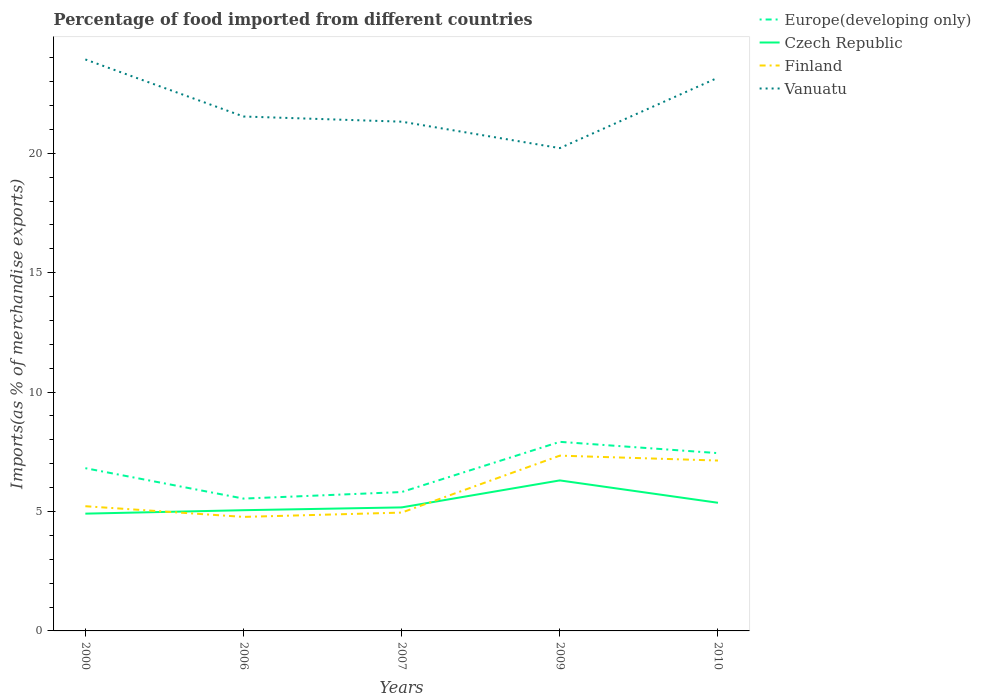How many different coloured lines are there?
Offer a very short reply. 4. Is the number of lines equal to the number of legend labels?
Your response must be concise. Yes. Across all years, what is the maximum percentage of imports to different countries in Europe(developing only)?
Your answer should be compact. 5.54. In which year was the percentage of imports to different countries in Europe(developing only) maximum?
Ensure brevity in your answer.  2006. What is the total percentage of imports to different countries in Finland in the graph?
Offer a terse response. -2.18. What is the difference between the highest and the second highest percentage of imports to different countries in Vanuatu?
Ensure brevity in your answer.  3.71. Is the percentage of imports to different countries in Vanuatu strictly greater than the percentage of imports to different countries in Europe(developing only) over the years?
Your response must be concise. No. How many years are there in the graph?
Keep it short and to the point. 5. Does the graph contain any zero values?
Your answer should be very brief. No. How are the legend labels stacked?
Give a very brief answer. Vertical. What is the title of the graph?
Your answer should be very brief. Percentage of food imported from different countries. Does "Isle of Man" appear as one of the legend labels in the graph?
Make the answer very short. No. What is the label or title of the X-axis?
Your answer should be compact. Years. What is the label or title of the Y-axis?
Make the answer very short. Imports(as % of merchandise exports). What is the Imports(as % of merchandise exports) of Europe(developing only) in 2000?
Make the answer very short. 6.81. What is the Imports(as % of merchandise exports) of Czech Republic in 2000?
Make the answer very short. 4.91. What is the Imports(as % of merchandise exports) in Finland in 2000?
Provide a short and direct response. 5.22. What is the Imports(as % of merchandise exports) in Vanuatu in 2000?
Your answer should be very brief. 23.93. What is the Imports(as % of merchandise exports) in Europe(developing only) in 2006?
Make the answer very short. 5.54. What is the Imports(as % of merchandise exports) in Czech Republic in 2006?
Your answer should be very brief. 5.05. What is the Imports(as % of merchandise exports) in Finland in 2006?
Your response must be concise. 4.77. What is the Imports(as % of merchandise exports) of Vanuatu in 2006?
Your answer should be very brief. 21.54. What is the Imports(as % of merchandise exports) in Europe(developing only) in 2007?
Provide a short and direct response. 5.82. What is the Imports(as % of merchandise exports) of Czech Republic in 2007?
Keep it short and to the point. 5.17. What is the Imports(as % of merchandise exports) in Finland in 2007?
Give a very brief answer. 4.96. What is the Imports(as % of merchandise exports) in Vanuatu in 2007?
Provide a succinct answer. 21.32. What is the Imports(as % of merchandise exports) of Europe(developing only) in 2009?
Provide a succinct answer. 7.92. What is the Imports(as % of merchandise exports) in Czech Republic in 2009?
Keep it short and to the point. 6.3. What is the Imports(as % of merchandise exports) of Finland in 2009?
Your answer should be compact. 7.34. What is the Imports(as % of merchandise exports) of Vanuatu in 2009?
Provide a succinct answer. 20.22. What is the Imports(as % of merchandise exports) of Europe(developing only) in 2010?
Provide a short and direct response. 7.45. What is the Imports(as % of merchandise exports) of Czech Republic in 2010?
Your answer should be compact. 5.37. What is the Imports(as % of merchandise exports) of Finland in 2010?
Your answer should be compact. 7.13. What is the Imports(as % of merchandise exports) in Vanuatu in 2010?
Ensure brevity in your answer.  23.17. Across all years, what is the maximum Imports(as % of merchandise exports) in Europe(developing only)?
Your answer should be very brief. 7.92. Across all years, what is the maximum Imports(as % of merchandise exports) of Czech Republic?
Your response must be concise. 6.3. Across all years, what is the maximum Imports(as % of merchandise exports) of Finland?
Make the answer very short. 7.34. Across all years, what is the maximum Imports(as % of merchandise exports) in Vanuatu?
Offer a very short reply. 23.93. Across all years, what is the minimum Imports(as % of merchandise exports) in Europe(developing only)?
Ensure brevity in your answer.  5.54. Across all years, what is the minimum Imports(as % of merchandise exports) in Czech Republic?
Your response must be concise. 4.91. Across all years, what is the minimum Imports(as % of merchandise exports) of Finland?
Keep it short and to the point. 4.77. Across all years, what is the minimum Imports(as % of merchandise exports) in Vanuatu?
Your response must be concise. 20.22. What is the total Imports(as % of merchandise exports) of Europe(developing only) in the graph?
Offer a terse response. 33.53. What is the total Imports(as % of merchandise exports) in Czech Republic in the graph?
Give a very brief answer. 26.81. What is the total Imports(as % of merchandise exports) of Finland in the graph?
Offer a very short reply. 29.43. What is the total Imports(as % of merchandise exports) in Vanuatu in the graph?
Give a very brief answer. 110.18. What is the difference between the Imports(as % of merchandise exports) in Europe(developing only) in 2000 and that in 2006?
Make the answer very short. 1.27. What is the difference between the Imports(as % of merchandise exports) of Czech Republic in 2000 and that in 2006?
Offer a terse response. -0.14. What is the difference between the Imports(as % of merchandise exports) in Finland in 2000 and that in 2006?
Provide a succinct answer. 0.45. What is the difference between the Imports(as % of merchandise exports) of Vanuatu in 2000 and that in 2006?
Provide a succinct answer. 2.39. What is the difference between the Imports(as % of merchandise exports) in Czech Republic in 2000 and that in 2007?
Ensure brevity in your answer.  -0.26. What is the difference between the Imports(as % of merchandise exports) of Finland in 2000 and that in 2007?
Your answer should be very brief. 0.27. What is the difference between the Imports(as % of merchandise exports) in Vanuatu in 2000 and that in 2007?
Offer a terse response. 2.61. What is the difference between the Imports(as % of merchandise exports) of Europe(developing only) in 2000 and that in 2009?
Keep it short and to the point. -1.1. What is the difference between the Imports(as % of merchandise exports) in Czech Republic in 2000 and that in 2009?
Offer a terse response. -1.39. What is the difference between the Imports(as % of merchandise exports) in Finland in 2000 and that in 2009?
Offer a terse response. -2.12. What is the difference between the Imports(as % of merchandise exports) of Vanuatu in 2000 and that in 2009?
Make the answer very short. 3.71. What is the difference between the Imports(as % of merchandise exports) of Europe(developing only) in 2000 and that in 2010?
Offer a terse response. -0.63. What is the difference between the Imports(as % of merchandise exports) in Czech Republic in 2000 and that in 2010?
Provide a short and direct response. -0.46. What is the difference between the Imports(as % of merchandise exports) of Finland in 2000 and that in 2010?
Your answer should be compact. -1.91. What is the difference between the Imports(as % of merchandise exports) of Vanuatu in 2000 and that in 2010?
Offer a terse response. 0.76. What is the difference between the Imports(as % of merchandise exports) in Europe(developing only) in 2006 and that in 2007?
Your response must be concise. -0.27. What is the difference between the Imports(as % of merchandise exports) in Czech Republic in 2006 and that in 2007?
Your answer should be compact. -0.12. What is the difference between the Imports(as % of merchandise exports) of Finland in 2006 and that in 2007?
Provide a short and direct response. -0.18. What is the difference between the Imports(as % of merchandise exports) of Vanuatu in 2006 and that in 2007?
Offer a very short reply. 0.22. What is the difference between the Imports(as % of merchandise exports) of Europe(developing only) in 2006 and that in 2009?
Provide a succinct answer. -2.38. What is the difference between the Imports(as % of merchandise exports) of Czech Republic in 2006 and that in 2009?
Your response must be concise. -1.25. What is the difference between the Imports(as % of merchandise exports) in Finland in 2006 and that in 2009?
Offer a terse response. -2.57. What is the difference between the Imports(as % of merchandise exports) of Vanuatu in 2006 and that in 2009?
Offer a terse response. 1.32. What is the difference between the Imports(as % of merchandise exports) of Europe(developing only) in 2006 and that in 2010?
Your response must be concise. -1.9. What is the difference between the Imports(as % of merchandise exports) in Czech Republic in 2006 and that in 2010?
Offer a very short reply. -0.31. What is the difference between the Imports(as % of merchandise exports) in Finland in 2006 and that in 2010?
Your answer should be compact. -2.36. What is the difference between the Imports(as % of merchandise exports) in Vanuatu in 2006 and that in 2010?
Provide a succinct answer. -1.63. What is the difference between the Imports(as % of merchandise exports) in Europe(developing only) in 2007 and that in 2009?
Give a very brief answer. -2.1. What is the difference between the Imports(as % of merchandise exports) in Czech Republic in 2007 and that in 2009?
Provide a short and direct response. -1.13. What is the difference between the Imports(as % of merchandise exports) of Finland in 2007 and that in 2009?
Your answer should be very brief. -2.38. What is the difference between the Imports(as % of merchandise exports) in Vanuatu in 2007 and that in 2009?
Your response must be concise. 1.11. What is the difference between the Imports(as % of merchandise exports) in Europe(developing only) in 2007 and that in 2010?
Your answer should be compact. -1.63. What is the difference between the Imports(as % of merchandise exports) of Czech Republic in 2007 and that in 2010?
Offer a very short reply. -0.19. What is the difference between the Imports(as % of merchandise exports) of Finland in 2007 and that in 2010?
Ensure brevity in your answer.  -2.18. What is the difference between the Imports(as % of merchandise exports) of Vanuatu in 2007 and that in 2010?
Keep it short and to the point. -1.84. What is the difference between the Imports(as % of merchandise exports) of Europe(developing only) in 2009 and that in 2010?
Offer a terse response. 0.47. What is the difference between the Imports(as % of merchandise exports) of Czech Republic in 2009 and that in 2010?
Provide a succinct answer. 0.94. What is the difference between the Imports(as % of merchandise exports) in Finland in 2009 and that in 2010?
Ensure brevity in your answer.  0.21. What is the difference between the Imports(as % of merchandise exports) in Vanuatu in 2009 and that in 2010?
Provide a short and direct response. -2.95. What is the difference between the Imports(as % of merchandise exports) of Europe(developing only) in 2000 and the Imports(as % of merchandise exports) of Czech Republic in 2006?
Ensure brevity in your answer.  1.76. What is the difference between the Imports(as % of merchandise exports) in Europe(developing only) in 2000 and the Imports(as % of merchandise exports) in Finland in 2006?
Your answer should be very brief. 2.04. What is the difference between the Imports(as % of merchandise exports) of Europe(developing only) in 2000 and the Imports(as % of merchandise exports) of Vanuatu in 2006?
Ensure brevity in your answer.  -14.73. What is the difference between the Imports(as % of merchandise exports) in Czech Republic in 2000 and the Imports(as % of merchandise exports) in Finland in 2006?
Ensure brevity in your answer.  0.14. What is the difference between the Imports(as % of merchandise exports) in Czech Republic in 2000 and the Imports(as % of merchandise exports) in Vanuatu in 2006?
Keep it short and to the point. -16.63. What is the difference between the Imports(as % of merchandise exports) in Finland in 2000 and the Imports(as % of merchandise exports) in Vanuatu in 2006?
Your response must be concise. -16.32. What is the difference between the Imports(as % of merchandise exports) of Europe(developing only) in 2000 and the Imports(as % of merchandise exports) of Czech Republic in 2007?
Give a very brief answer. 1.64. What is the difference between the Imports(as % of merchandise exports) in Europe(developing only) in 2000 and the Imports(as % of merchandise exports) in Finland in 2007?
Give a very brief answer. 1.86. What is the difference between the Imports(as % of merchandise exports) in Europe(developing only) in 2000 and the Imports(as % of merchandise exports) in Vanuatu in 2007?
Provide a succinct answer. -14.51. What is the difference between the Imports(as % of merchandise exports) in Czech Republic in 2000 and the Imports(as % of merchandise exports) in Finland in 2007?
Ensure brevity in your answer.  -0.04. What is the difference between the Imports(as % of merchandise exports) in Czech Republic in 2000 and the Imports(as % of merchandise exports) in Vanuatu in 2007?
Your answer should be very brief. -16.41. What is the difference between the Imports(as % of merchandise exports) of Finland in 2000 and the Imports(as % of merchandise exports) of Vanuatu in 2007?
Your answer should be very brief. -16.1. What is the difference between the Imports(as % of merchandise exports) of Europe(developing only) in 2000 and the Imports(as % of merchandise exports) of Czech Republic in 2009?
Ensure brevity in your answer.  0.51. What is the difference between the Imports(as % of merchandise exports) in Europe(developing only) in 2000 and the Imports(as % of merchandise exports) in Finland in 2009?
Give a very brief answer. -0.53. What is the difference between the Imports(as % of merchandise exports) of Europe(developing only) in 2000 and the Imports(as % of merchandise exports) of Vanuatu in 2009?
Provide a succinct answer. -13.4. What is the difference between the Imports(as % of merchandise exports) of Czech Republic in 2000 and the Imports(as % of merchandise exports) of Finland in 2009?
Provide a short and direct response. -2.43. What is the difference between the Imports(as % of merchandise exports) of Czech Republic in 2000 and the Imports(as % of merchandise exports) of Vanuatu in 2009?
Give a very brief answer. -15.31. What is the difference between the Imports(as % of merchandise exports) of Finland in 2000 and the Imports(as % of merchandise exports) of Vanuatu in 2009?
Ensure brevity in your answer.  -15. What is the difference between the Imports(as % of merchandise exports) of Europe(developing only) in 2000 and the Imports(as % of merchandise exports) of Czech Republic in 2010?
Your answer should be compact. 1.45. What is the difference between the Imports(as % of merchandise exports) in Europe(developing only) in 2000 and the Imports(as % of merchandise exports) in Finland in 2010?
Provide a succinct answer. -0.32. What is the difference between the Imports(as % of merchandise exports) in Europe(developing only) in 2000 and the Imports(as % of merchandise exports) in Vanuatu in 2010?
Keep it short and to the point. -16.35. What is the difference between the Imports(as % of merchandise exports) of Czech Republic in 2000 and the Imports(as % of merchandise exports) of Finland in 2010?
Your answer should be compact. -2.22. What is the difference between the Imports(as % of merchandise exports) in Czech Republic in 2000 and the Imports(as % of merchandise exports) in Vanuatu in 2010?
Ensure brevity in your answer.  -18.26. What is the difference between the Imports(as % of merchandise exports) of Finland in 2000 and the Imports(as % of merchandise exports) of Vanuatu in 2010?
Provide a succinct answer. -17.95. What is the difference between the Imports(as % of merchandise exports) in Europe(developing only) in 2006 and the Imports(as % of merchandise exports) in Czech Republic in 2007?
Offer a terse response. 0.37. What is the difference between the Imports(as % of merchandise exports) of Europe(developing only) in 2006 and the Imports(as % of merchandise exports) of Finland in 2007?
Your answer should be very brief. 0.59. What is the difference between the Imports(as % of merchandise exports) in Europe(developing only) in 2006 and the Imports(as % of merchandise exports) in Vanuatu in 2007?
Your answer should be compact. -15.78. What is the difference between the Imports(as % of merchandise exports) of Czech Republic in 2006 and the Imports(as % of merchandise exports) of Finland in 2007?
Keep it short and to the point. 0.1. What is the difference between the Imports(as % of merchandise exports) of Czech Republic in 2006 and the Imports(as % of merchandise exports) of Vanuatu in 2007?
Provide a short and direct response. -16.27. What is the difference between the Imports(as % of merchandise exports) in Finland in 2006 and the Imports(as % of merchandise exports) in Vanuatu in 2007?
Provide a short and direct response. -16.55. What is the difference between the Imports(as % of merchandise exports) in Europe(developing only) in 2006 and the Imports(as % of merchandise exports) in Czech Republic in 2009?
Make the answer very short. -0.76. What is the difference between the Imports(as % of merchandise exports) in Europe(developing only) in 2006 and the Imports(as % of merchandise exports) in Finland in 2009?
Ensure brevity in your answer.  -1.8. What is the difference between the Imports(as % of merchandise exports) in Europe(developing only) in 2006 and the Imports(as % of merchandise exports) in Vanuatu in 2009?
Ensure brevity in your answer.  -14.68. What is the difference between the Imports(as % of merchandise exports) of Czech Republic in 2006 and the Imports(as % of merchandise exports) of Finland in 2009?
Your response must be concise. -2.29. What is the difference between the Imports(as % of merchandise exports) of Czech Republic in 2006 and the Imports(as % of merchandise exports) of Vanuatu in 2009?
Provide a short and direct response. -15.16. What is the difference between the Imports(as % of merchandise exports) of Finland in 2006 and the Imports(as % of merchandise exports) of Vanuatu in 2009?
Your answer should be very brief. -15.44. What is the difference between the Imports(as % of merchandise exports) in Europe(developing only) in 2006 and the Imports(as % of merchandise exports) in Czech Republic in 2010?
Your answer should be very brief. 0.17. What is the difference between the Imports(as % of merchandise exports) in Europe(developing only) in 2006 and the Imports(as % of merchandise exports) in Finland in 2010?
Your response must be concise. -1.59. What is the difference between the Imports(as % of merchandise exports) in Europe(developing only) in 2006 and the Imports(as % of merchandise exports) in Vanuatu in 2010?
Keep it short and to the point. -17.63. What is the difference between the Imports(as % of merchandise exports) in Czech Republic in 2006 and the Imports(as % of merchandise exports) in Finland in 2010?
Offer a terse response. -2.08. What is the difference between the Imports(as % of merchandise exports) in Czech Republic in 2006 and the Imports(as % of merchandise exports) in Vanuatu in 2010?
Keep it short and to the point. -18.11. What is the difference between the Imports(as % of merchandise exports) in Finland in 2006 and the Imports(as % of merchandise exports) in Vanuatu in 2010?
Ensure brevity in your answer.  -18.39. What is the difference between the Imports(as % of merchandise exports) of Europe(developing only) in 2007 and the Imports(as % of merchandise exports) of Czech Republic in 2009?
Provide a short and direct response. -0.49. What is the difference between the Imports(as % of merchandise exports) of Europe(developing only) in 2007 and the Imports(as % of merchandise exports) of Finland in 2009?
Provide a succinct answer. -1.52. What is the difference between the Imports(as % of merchandise exports) of Europe(developing only) in 2007 and the Imports(as % of merchandise exports) of Vanuatu in 2009?
Ensure brevity in your answer.  -14.4. What is the difference between the Imports(as % of merchandise exports) in Czech Republic in 2007 and the Imports(as % of merchandise exports) in Finland in 2009?
Your response must be concise. -2.17. What is the difference between the Imports(as % of merchandise exports) in Czech Republic in 2007 and the Imports(as % of merchandise exports) in Vanuatu in 2009?
Give a very brief answer. -15.04. What is the difference between the Imports(as % of merchandise exports) in Finland in 2007 and the Imports(as % of merchandise exports) in Vanuatu in 2009?
Your answer should be very brief. -15.26. What is the difference between the Imports(as % of merchandise exports) in Europe(developing only) in 2007 and the Imports(as % of merchandise exports) in Czech Republic in 2010?
Your answer should be compact. 0.45. What is the difference between the Imports(as % of merchandise exports) in Europe(developing only) in 2007 and the Imports(as % of merchandise exports) in Finland in 2010?
Keep it short and to the point. -1.32. What is the difference between the Imports(as % of merchandise exports) in Europe(developing only) in 2007 and the Imports(as % of merchandise exports) in Vanuatu in 2010?
Make the answer very short. -17.35. What is the difference between the Imports(as % of merchandise exports) in Czech Republic in 2007 and the Imports(as % of merchandise exports) in Finland in 2010?
Your answer should be very brief. -1.96. What is the difference between the Imports(as % of merchandise exports) in Czech Republic in 2007 and the Imports(as % of merchandise exports) in Vanuatu in 2010?
Offer a terse response. -17.99. What is the difference between the Imports(as % of merchandise exports) of Finland in 2007 and the Imports(as % of merchandise exports) of Vanuatu in 2010?
Give a very brief answer. -18.21. What is the difference between the Imports(as % of merchandise exports) in Europe(developing only) in 2009 and the Imports(as % of merchandise exports) in Czech Republic in 2010?
Ensure brevity in your answer.  2.55. What is the difference between the Imports(as % of merchandise exports) in Europe(developing only) in 2009 and the Imports(as % of merchandise exports) in Finland in 2010?
Your answer should be very brief. 0.78. What is the difference between the Imports(as % of merchandise exports) of Europe(developing only) in 2009 and the Imports(as % of merchandise exports) of Vanuatu in 2010?
Your response must be concise. -15.25. What is the difference between the Imports(as % of merchandise exports) of Czech Republic in 2009 and the Imports(as % of merchandise exports) of Finland in 2010?
Your answer should be compact. -0.83. What is the difference between the Imports(as % of merchandise exports) in Czech Republic in 2009 and the Imports(as % of merchandise exports) in Vanuatu in 2010?
Your response must be concise. -16.86. What is the difference between the Imports(as % of merchandise exports) of Finland in 2009 and the Imports(as % of merchandise exports) of Vanuatu in 2010?
Give a very brief answer. -15.83. What is the average Imports(as % of merchandise exports) in Europe(developing only) per year?
Offer a terse response. 6.71. What is the average Imports(as % of merchandise exports) in Czech Republic per year?
Make the answer very short. 5.36. What is the average Imports(as % of merchandise exports) of Finland per year?
Your answer should be very brief. 5.89. What is the average Imports(as % of merchandise exports) of Vanuatu per year?
Your answer should be very brief. 22.04. In the year 2000, what is the difference between the Imports(as % of merchandise exports) of Europe(developing only) and Imports(as % of merchandise exports) of Czech Republic?
Keep it short and to the point. 1.9. In the year 2000, what is the difference between the Imports(as % of merchandise exports) of Europe(developing only) and Imports(as % of merchandise exports) of Finland?
Keep it short and to the point. 1.59. In the year 2000, what is the difference between the Imports(as % of merchandise exports) of Europe(developing only) and Imports(as % of merchandise exports) of Vanuatu?
Offer a very short reply. -17.12. In the year 2000, what is the difference between the Imports(as % of merchandise exports) in Czech Republic and Imports(as % of merchandise exports) in Finland?
Provide a short and direct response. -0.31. In the year 2000, what is the difference between the Imports(as % of merchandise exports) of Czech Republic and Imports(as % of merchandise exports) of Vanuatu?
Keep it short and to the point. -19.02. In the year 2000, what is the difference between the Imports(as % of merchandise exports) in Finland and Imports(as % of merchandise exports) in Vanuatu?
Keep it short and to the point. -18.71. In the year 2006, what is the difference between the Imports(as % of merchandise exports) in Europe(developing only) and Imports(as % of merchandise exports) in Czech Republic?
Offer a very short reply. 0.49. In the year 2006, what is the difference between the Imports(as % of merchandise exports) of Europe(developing only) and Imports(as % of merchandise exports) of Finland?
Your answer should be compact. 0.77. In the year 2006, what is the difference between the Imports(as % of merchandise exports) in Europe(developing only) and Imports(as % of merchandise exports) in Vanuatu?
Ensure brevity in your answer.  -16. In the year 2006, what is the difference between the Imports(as % of merchandise exports) of Czech Republic and Imports(as % of merchandise exports) of Finland?
Offer a terse response. 0.28. In the year 2006, what is the difference between the Imports(as % of merchandise exports) in Czech Republic and Imports(as % of merchandise exports) in Vanuatu?
Your answer should be compact. -16.49. In the year 2006, what is the difference between the Imports(as % of merchandise exports) of Finland and Imports(as % of merchandise exports) of Vanuatu?
Provide a short and direct response. -16.77. In the year 2007, what is the difference between the Imports(as % of merchandise exports) in Europe(developing only) and Imports(as % of merchandise exports) in Czech Republic?
Your answer should be compact. 0.64. In the year 2007, what is the difference between the Imports(as % of merchandise exports) in Europe(developing only) and Imports(as % of merchandise exports) in Finland?
Your answer should be very brief. 0.86. In the year 2007, what is the difference between the Imports(as % of merchandise exports) in Europe(developing only) and Imports(as % of merchandise exports) in Vanuatu?
Provide a succinct answer. -15.51. In the year 2007, what is the difference between the Imports(as % of merchandise exports) of Czech Republic and Imports(as % of merchandise exports) of Finland?
Give a very brief answer. 0.22. In the year 2007, what is the difference between the Imports(as % of merchandise exports) in Czech Republic and Imports(as % of merchandise exports) in Vanuatu?
Keep it short and to the point. -16.15. In the year 2007, what is the difference between the Imports(as % of merchandise exports) in Finland and Imports(as % of merchandise exports) in Vanuatu?
Offer a terse response. -16.37. In the year 2009, what is the difference between the Imports(as % of merchandise exports) in Europe(developing only) and Imports(as % of merchandise exports) in Czech Republic?
Your answer should be very brief. 1.62. In the year 2009, what is the difference between the Imports(as % of merchandise exports) of Europe(developing only) and Imports(as % of merchandise exports) of Finland?
Your response must be concise. 0.58. In the year 2009, what is the difference between the Imports(as % of merchandise exports) of Europe(developing only) and Imports(as % of merchandise exports) of Vanuatu?
Keep it short and to the point. -12.3. In the year 2009, what is the difference between the Imports(as % of merchandise exports) in Czech Republic and Imports(as % of merchandise exports) in Finland?
Offer a terse response. -1.04. In the year 2009, what is the difference between the Imports(as % of merchandise exports) of Czech Republic and Imports(as % of merchandise exports) of Vanuatu?
Ensure brevity in your answer.  -13.91. In the year 2009, what is the difference between the Imports(as % of merchandise exports) of Finland and Imports(as % of merchandise exports) of Vanuatu?
Make the answer very short. -12.88. In the year 2010, what is the difference between the Imports(as % of merchandise exports) of Europe(developing only) and Imports(as % of merchandise exports) of Czech Republic?
Give a very brief answer. 2.08. In the year 2010, what is the difference between the Imports(as % of merchandise exports) in Europe(developing only) and Imports(as % of merchandise exports) in Finland?
Your answer should be very brief. 0.31. In the year 2010, what is the difference between the Imports(as % of merchandise exports) of Europe(developing only) and Imports(as % of merchandise exports) of Vanuatu?
Keep it short and to the point. -15.72. In the year 2010, what is the difference between the Imports(as % of merchandise exports) in Czech Republic and Imports(as % of merchandise exports) in Finland?
Provide a succinct answer. -1.77. In the year 2010, what is the difference between the Imports(as % of merchandise exports) of Czech Republic and Imports(as % of merchandise exports) of Vanuatu?
Provide a succinct answer. -17.8. In the year 2010, what is the difference between the Imports(as % of merchandise exports) of Finland and Imports(as % of merchandise exports) of Vanuatu?
Your response must be concise. -16.03. What is the ratio of the Imports(as % of merchandise exports) in Europe(developing only) in 2000 to that in 2006?
Keep it short and to the point. 1.23. What is the ratio of the Imports(as % of merchandise exports) of Czech Republic in 2000 to that in 2006?
Offer a terse response. 0.97. What is the ratio of the Imports(as % of merchandise exports) of Finland in 2000 to that in 2006?
Offer a terse response. 1.09. What is the ratio of the Imports(as % of merchandise exports) of Vanuatu in 2000 to that in 2006?
Your answer should be very brief. 1.11. What is the ratio of the Imports(as % of merchandise exports) in Europe(developing only) in 2000 to that in 2007?
Ensure brevity in your answer.  1.17. What is the ratio of the Imports(as % of merchandise exports) in Czech Republic in 2000 to that in 2007?
Keep it short and to the point. 0.95. What is the ratio of the Imports(as % of merchandise exports) of Finland in 2000 to that in 2007?
Provide a short and direct response. 1.05. What is the ratio of the Imports(as % of merchandise exports) of Vanuatu in 2000 to that in 2007?
Ensure brevity in your answer.  1.12. What is the ratio of the Imports(as % of merchandise exports) in Europe(developing only) in 2000 to that in 2009?
Give a very brief answer. 0.86. What is the ratio of the Imports(as % of merchandise exports) in Czech Republic in 2000 to that in 2009?
Your response must be concise. 0.78. What is the ratio of the Imports(as % of merchandise exports) in Finland in 2000 to that in 2009?
Provide a succinct answer. 0.71. What is the ratio of the Imports(as % of merchandise exports) of Vanuatu in 2000 to that in 2009?
Your answer should be very brief. 1.18. What is the ratio of the Imports(as % of merchandise exports) in Europe(developing only) in 2000 to that in 2010?
Make the answer very short. 0.92. What is the ratio of the Imports(as % of merchandise exports) in Czech Republic in 2000 to that in 2010?
Your answer should be very brief. 0.92. What is the ratio of the Imports(as % of merchandise exports) in Finland in 2000 to that in 2010?
Offer a terse response. 0.73. What is the ratio of the Imports(as % of merchandise exports) in Vanuatu in 2000 to that in 2010?
Your response must be concise. 1.03. What is the ratio of the Imports(as % of merchandise exports) in Europe(developing only) in 2006 to that in 2007?
Offer a very short reply. 0.95. What is the ratio of the Imports(as % of merchandise exports) of Czech Republic in 2006 to that in 2007?
Offer a terse response. 0.98. What is the ratio of the Imports(as % of merchandise exports) of Finland in 2006 to that in 2007?
Give a very brief answer. 0.96. What is the ratio of the Imports(as % of merchandise exports) in Vanuatu in 2006 to that in 2007?
Keep it short and to the point. 1.01. What is the ratio of the Imports(as % of merchandise exports) of Europe(developing only) in 2006 to that in 2009?
Keep it short and to the point. 0.7. What is the ratio of the Imports(as % of merchandise exports) of Czech Republic in 2006 to that in 2009?
Give a very brief answer. 0.8. What is the ratio of the Imports(as % of merchandise exports) in Finland in 2006 to that in 2009?
Make the answer very short. 0.65. What is the ratio of the Imports(as % of merchandise exports) in Vanuatu in 2006 to that in 2009?
Ensure brevity in your answer.  1.07. What is the ratio of the Imports(as % of merchandise exports) in Europe(developing only) in 2006 to that in 2010?
Offer a terse response. 0.74. What is the ratio of the Imports(as % of merchandise exports) in Czech Republic in 2006 to that in 2010?
Make the answer very short. 0.94. What is the ratio of the Imports(as % of merchandise exports) of Finland in 2006 to that in 2010?
Give a very brief answer. 0.67. What is the ratio of the Imports(as % of merchandise exports) in Vanuatu in 2006 to that in 2010?
Ensure brevity in your answer.  0.93. What is the ratio of the Imports(as % of merchandise exports) of Europe(developing only) in 2007 to that in 2009?
Your response must be concise. 0.73. What is the ratio of the Imports(as % of merchandise exports) in Czech Republic in 2007 to that in 2009?
Offer a terse response. 0.82. What is the ratio of the Imports(as % of merchandise exports) of Finland in 2007 to that in 2009?
Ensure brevity in your answer.  0.68. What is the ratio of the Imports(as % of merchandise exports) in Vanuatu in 2007 to that in 2009?
Offer a terse response. 1.05. What is the ratio of the Imports(as % of merchandise exports) in Europe(developing only) in 2007 to that in 2010?
Provide a succinct answer. 0.78. What is the ratio of the Imports(as % of merchandise exports) of Czech Republic in 2007 to that in 2010?
Give a very brief answer. 0.96. What is the ratio of the Imports(as % of merchandise exports) in Finland in 2007 to that in 2010?
Make the answer very short. 0.69. What is the ratio of the Imports(as % of merchandise exports) of Vanuatu in 2007 to that in 2010?
Make the answer very short. 0.92. What is the ratio of the Imports(as % of merchandise exports) of Europe(developing only) in 2009 to that in 2010?
Offer a terse response. 1.06. What is the ratio of the Imports(as % of merchandise exports) in Czech Republic in 2009 to that in 2010?
Provide a short and direct response. 1.17. What is the ratio of the Imports(as % of merchandise exports) in Finland in 2009 to that in 2010?
Keep it short and to the point. 1.03. What is the ratio of the Imports(as % of merchandise exports) of Vanuatu in 2009 to that in 2010?
Your answer should be very brief. 0.87. What is the difference between the highest and the second highest Imports(as % of merchandise exports) of Europe(developing only)?
Give a very brief answer. 0.47. What is the difference between the highest and the second highest Imports(as % of merchandise exports) in Czech Republic?
Your response must be concise. 0.94. What is the difference between the highest and the second highest Imports(as % of merchandise exports) in Finland?
Your answer should be compact. 0.21. What is the difference between the highest and the second highest Imports(as % of merchandise exports) of Vanuatu?
Your response must be concise. 0.76. What is the difference between the highest and the lowest Imports(as % of merchandise exports) in Europe(developing only)?
Your answer should be compact. 2.38. What is the difference between the highest and the lowest Imports(as % of merchandise exports) in Czech Republic?
Give a very brief answer. 1.39. What is the difference between the highest and the lowest Imports(as % of merchandise exports) of Finland?
Provide a succinct answer. 2.57. What is the difference between the highest and the lowest Imports(as % of merchandise exports) in Vanuatu?
Provide a succinct answer. 3.71. 